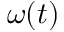<formula> <loc_0><loc_0><loc_500><loc_500>\omega ( t )</formula> 